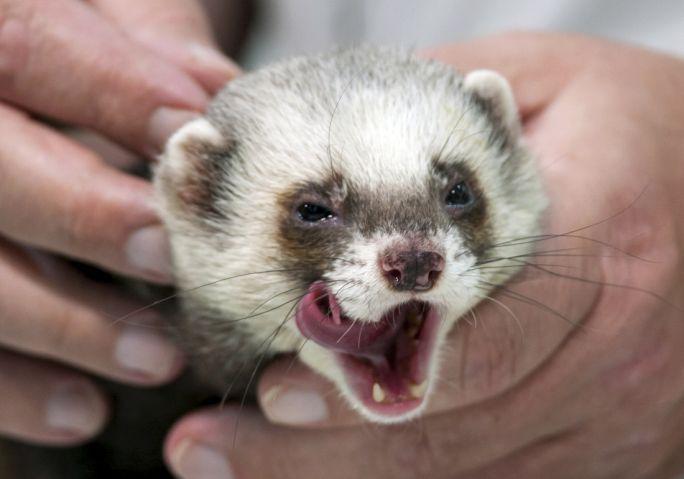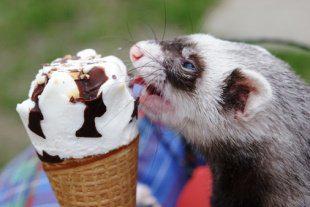The first image is the image on the left, the second image is the image on the right. Assess this claim about the two images: "A ferret with no food in front of it is """"licking its chops"""" with an upturned tongue.". Correct or not? Answer yes or no. Yes. The first image is the image on the left, the second image is the image on the right. Considering the images on both sides, is "The little animal in one image has its mouth wide open with tongue and two lower teeth showing, while a second little animal is eating in the second image." valid? Answer yes or no. Yes. 